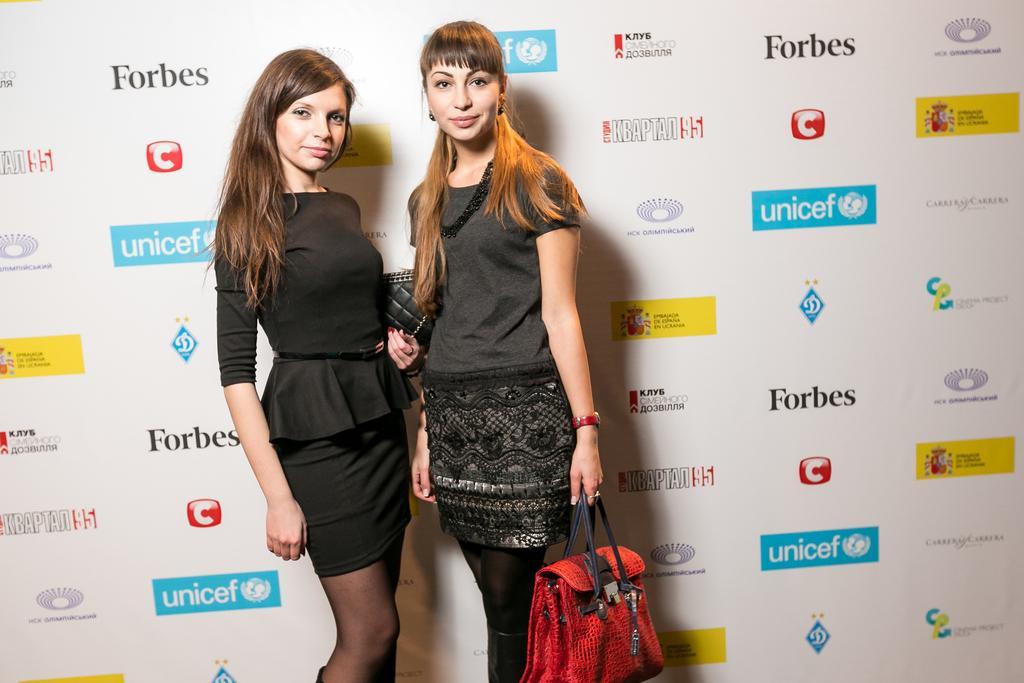How would you summarize this image in a sentence or two? In this picture we can see two women are standing and holding a bag and taking picture. 